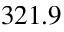Convert formula to latex. <formula><loc_0><loc_0><loc_500><loc_500>3 2 1 . 9</formula> 